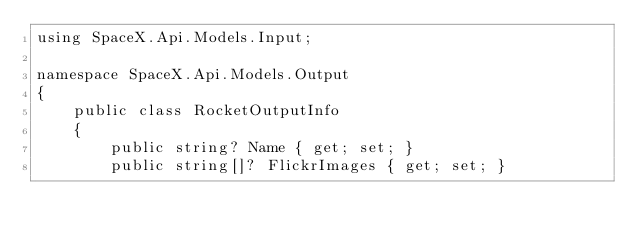<code> <loc_0><loc_0><loc_500><loc_500><_C#_>using SpaceX.Api.Models.Input;

namespace SpaceX.Api.Models.Output
{
    public class RocketOutputInfo
    {
        public string? Name { get; set; }
        public string[]? FlickrImages { get; set; }
</code> 